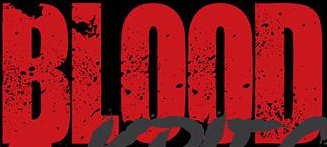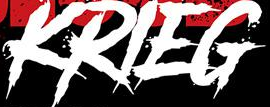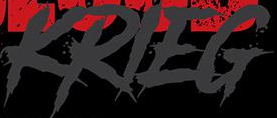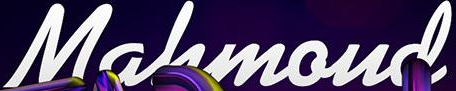What words can you see in these images in sequence, separated by a semicolon? BLOOD; KRIEG; KRIEG; Mahmoud 